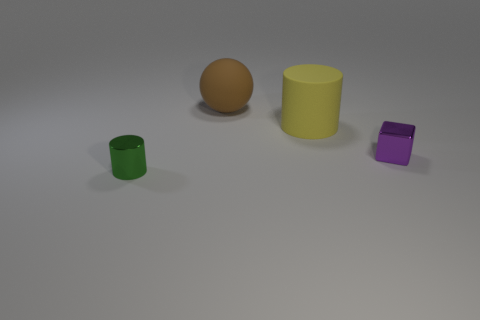Add 3 tiny purple rubber things. How many objects exist? 7 Subtract 1 cubes. How many cubes are left? 0 Subtract all yellow cylinders. How many cylinders are left? 1 Add 3 tiny purple metallic blocks. How many tiny purple metallic blocks are left? 4 Add 1 green rubber blocks. How many green rubber blocks exist? 1 Subtract 1 brown spheres. How many objects are left? 3 Subtract all blue spheres. Subtract all yellow cubes. How many spheres are left? 1 Subtract all gray spheres. How many cyan cylinders are left? 0 Subtract all large yellow cylinders. Subtract all small brown matte cubes. How many objects are left? 3 